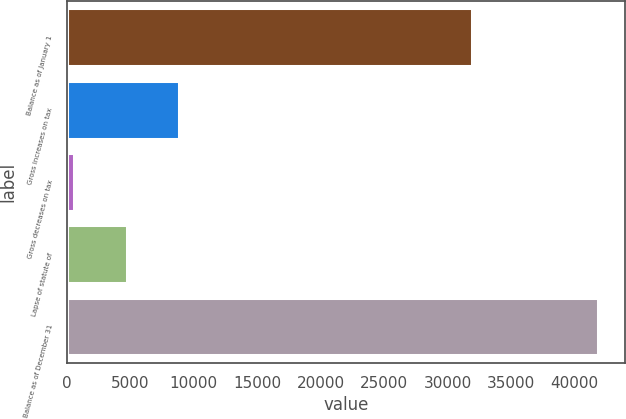<chart> <loc_0><loc_0><loc_500><loc_500><bar_chart><fcel>Balance as of January 1<fcel>Gross increases on tax<fcel>Gross decreases on tax<fcel>Lapse of statute of<fcel>Balance as of December 31<nl><fcel>31903<fcel>8860.6<fcel>608<fcel>4734.3<fcel>41871<nl></chart> 